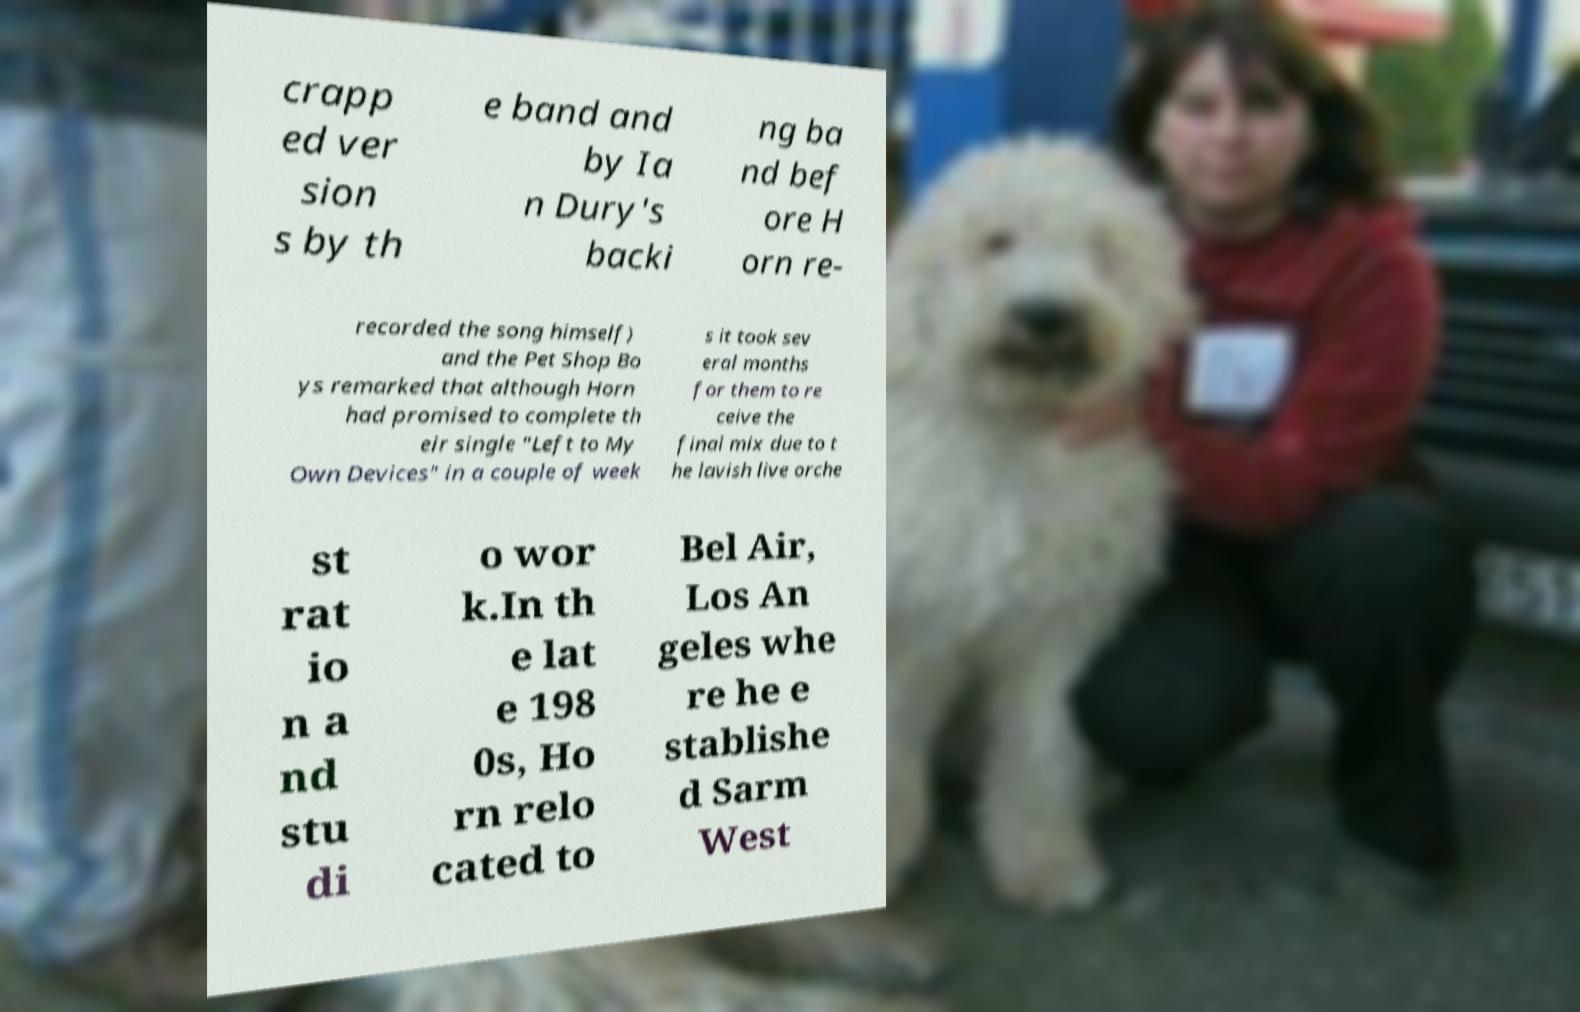What messages or text are displayed in this image? I need them in a readable, typed format. crapp ed ver sion s by th e band and by Ia n Dury's backi ng ba nd bef ore H orn re- recorded the song himself) and the Pet Shop Bo ys remarked that although Horn had promised to complete th eir single "Left to My Own Devices" in a couple of week s it took sev eral months for them to re ceive the final mix due to t he lavish live orche st rat io n a nd stu di o wor k.In th e lat e 198 0s, Ho rn relo cated to Bel Air, Los An geles whe re he e stablishe d Sarm West 